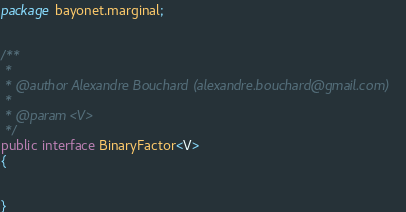<code> <loc_0><loc_0><loc_500><loc_500><_Java_>package bayonet.marginal;


/**
 * 
 * @author Alexandre Bouchard (alexandre.bouchard@gmail.com)
 *
 * @param <V>
 */
public interface BinaryFactor<V>
{


}
</code> 